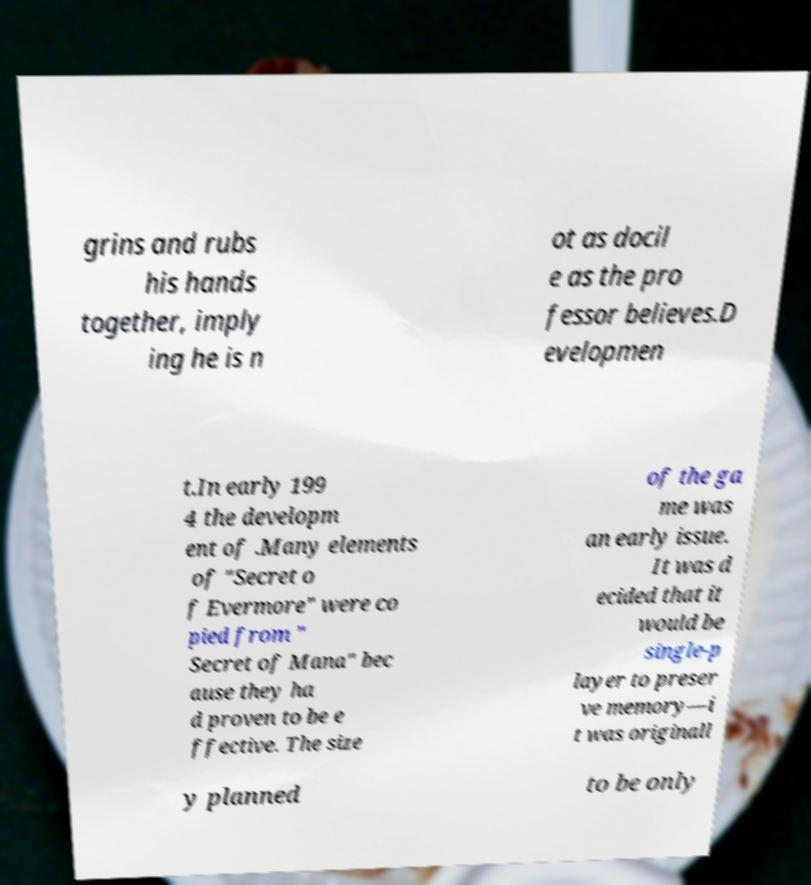Can you read and provide the text displayed in the image?This photo seems to have some interesting text. Can you extract and type it out for me? grins and rubs his hands together, imply ing he is n ot as docil e as the pro fessor believes.D evelopmen t.In early 199 4 the developm ent of .Many elements of "Secret o f Evermore" were co pied from " Secret of Mana" bec ause they ha d proven to be e ffective. The size of the ga me was an early issue. It was d ecided that it would be single-p layer to preser ve memory—i t was originall y planned to be only 